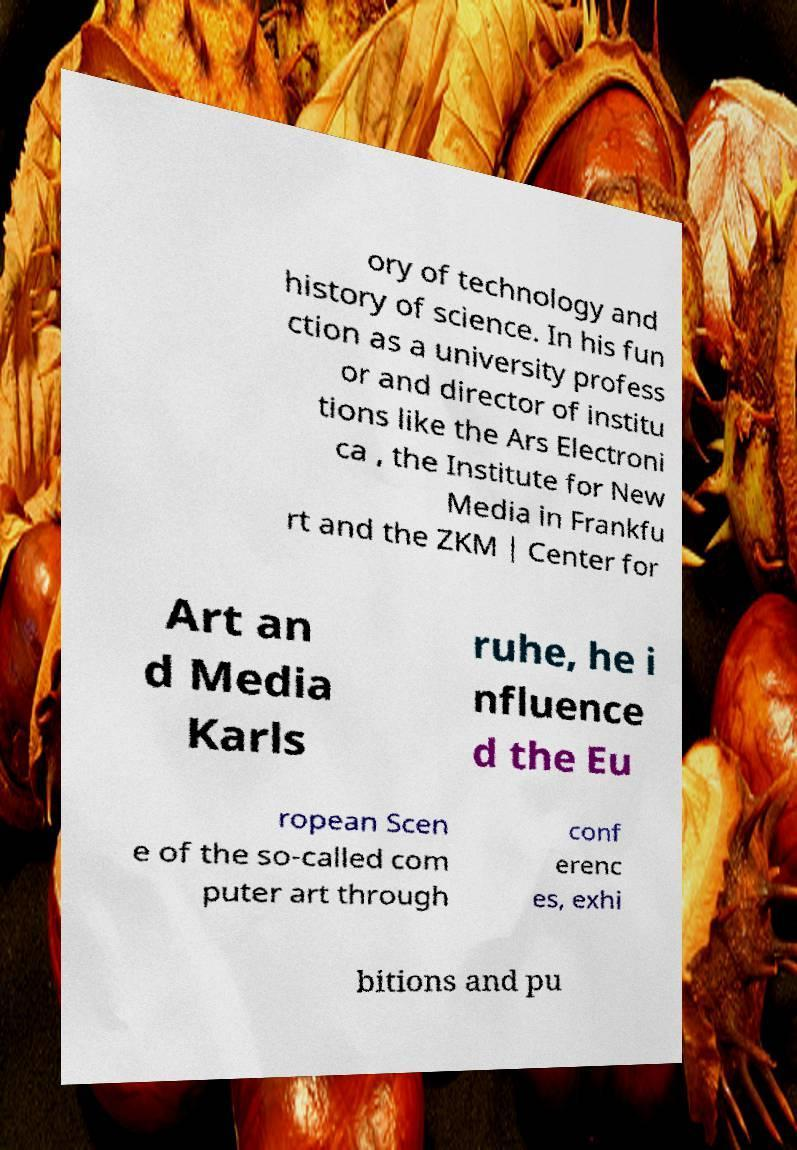Please identify and transcribe the text found in this image. ory of technology and history of science. In his fun ction as a university profess or and director of institu tions like the Ars Electroni ca , the Institute for New Media in Frankfu rt and the ZKM | Center for Art an d Media Karls ruhe, he i nfluence d the Eu ropean Scen e of the so-called com puter art through conf erenc es, exhi bitions and pu 